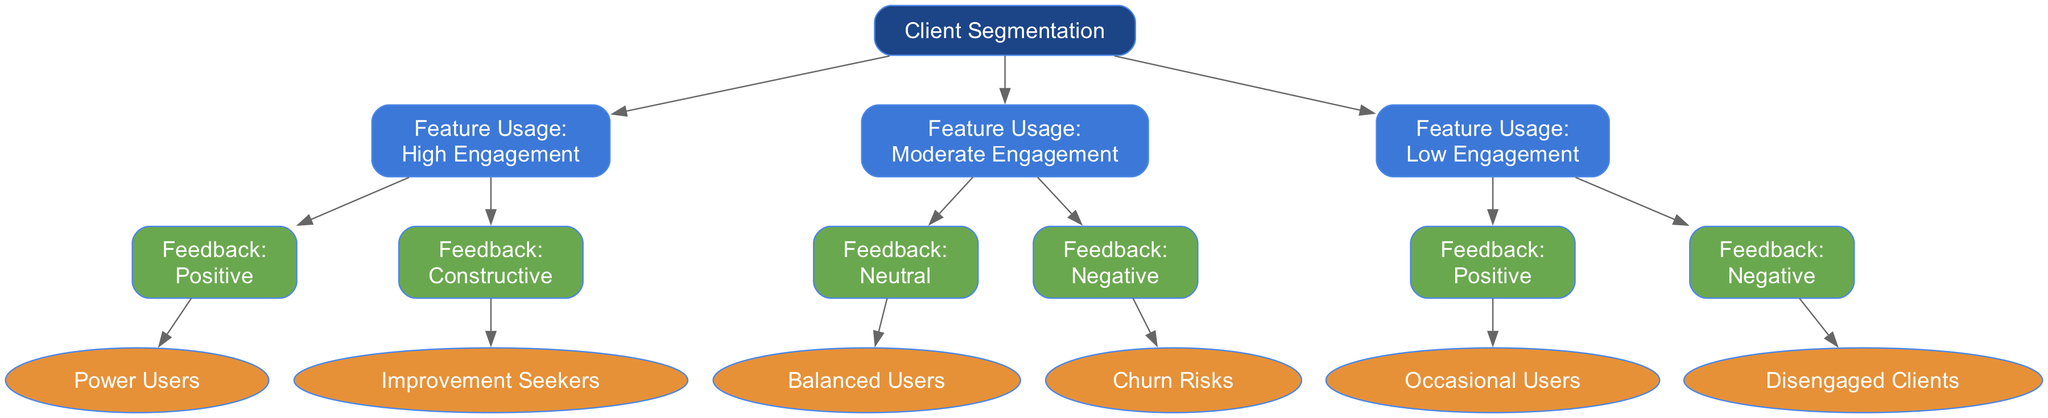What is the top-level category in the diagram? The diagram starts with a root node labeled "Client Segmentation," indicating that it is the primary category for the decision tree.
Answer: Client Segmentation How many primary levels are there under "Client Segmentation"? The first level under "Client Segmentation" is "Feature Usage," and it has three categories beneath it: "High Engagement," "Moderate Engagement," and "Low Engagement," totaling three primary levels.
Answer: 3 What are the two segments under "High Engagement"? Under the "High Engagement" category, two feedback types are present: "Positive" feedback leads to the segment "Power Users," while "Constructive" feedback leads to "Improvement Seekers."
Answer: Power Users, Improvement Seekers If a client shows "Negative" feedback with "Moderate Engagement," what are they classified as? The diagram indicates that when a client falls under "Moderate Engagement" and provides "Negative" feedback, they are categorized as "Churn Risks."
Answer: Churn Risks Which segment correlates with "Low Engagement" and "Positive" feedback? For clients that fall under "Low Engagement" with "Positive" feedback, the segment identified in the diagram is "Occasional Users."
Answer: Occasional Users What feedback type leads to "Balanced Users"? For clients with "Moderate Engagement" providing "Neutral" feedback, they are classified as "Balanced Users," which is depicted in the diagram.
Answer: Neutral Which segment is at the end of the path that begins with "High Engagement" and "Constructive"? Following the path from "High Engagement" to "Constructive" feedback, we conclude that the segment is "Improvement Seekers."
Answer: Improvement Seekers How many segments are there in total across all engagement levels? The segments are: "Power Users," "Improvement Seekers," "Balanced Users," "Churn Risks," "Occasional Users," and "Disengaged Clients," totaling six distinct segments.
Answer: 6 What is the direct connection between "Low Engagement" and "Negative" feedback in the diagram? Moving through the diagram, "Low Engagement" connected with "Negative" feedback leads to the segment "Disengaged Clients."
Answer: Disengaged Clients 